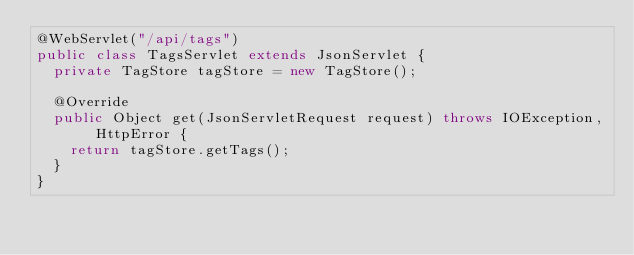Convert code to text. <code><loc_0><loc_0><loc_500><loc_500><_Java_>@WebServlet("/api/tags")
public class TagsServlet extends JsonServlet {
  private TagStore tagStore = new TagStore();

  @Override
  public Object get(JsonServletRequest request) throws IOException, HttpError {
    return tagStore.getTags();
  }
}
</code> 